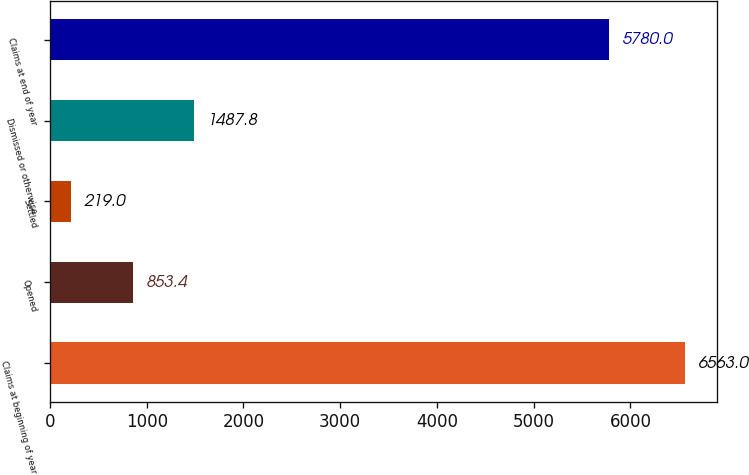Convert chart. <chart><loc_0><loc_0><loc_500><loc_500><bar_chart><fcel>Claims at beginning of year<fcel>Opened<fcel>Settled<fcel>Dismissed or otherwise<fcel>Claims at end of year<nl><fcel>6563<fcel>853.4<fcel>219<fcel>1487.8<fcel>5780<nl></chart> 